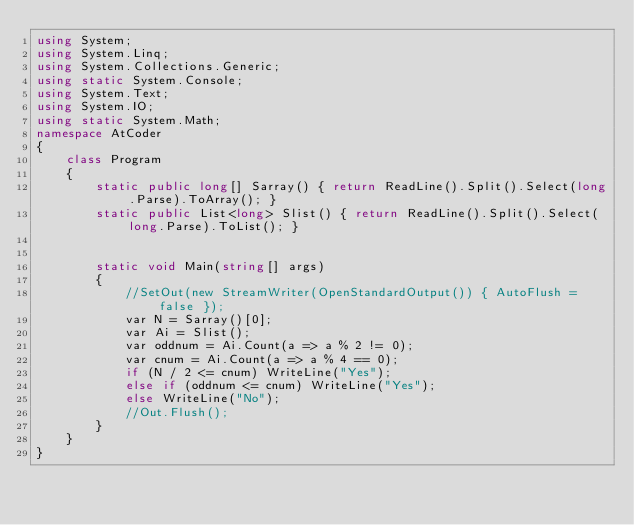<code> <loc_0><loc_0><loc_500><loc_500><_C#_>using System;
using System.Linq;
using System.Collections.Generic;
using static System.Console;
using System.Text;
using System.IO;
using static System.Math;
namespace AtCoder
{
    class Program
    {
        static public long[] Sarray() { return ReadLine().Split().Select(long.Parse).ToArray(); }
        static public List<long> Slist() { return ReadLine().Split().Select(long.Parse).ToList(); }


        static void Main(string[] args)
        {
            //SetOut(new StreamWriter(OpenStandardOutput()) { AutoFlush = false });
            var N = Sarray()[0];
            var Ai = Slist();
            var oddnum = Ai.Count(a => a % 2 != 0);
            var cnum = Ai.Count(a => a % 4 == 0);
            if (N / 2 <= cnum) WriteLine("Yes");
            else if (oddnum <= cnum) WriteLine("Yes");
            else WriteLine("No");
            //Out.Flush();
        }
    }
}</code> 